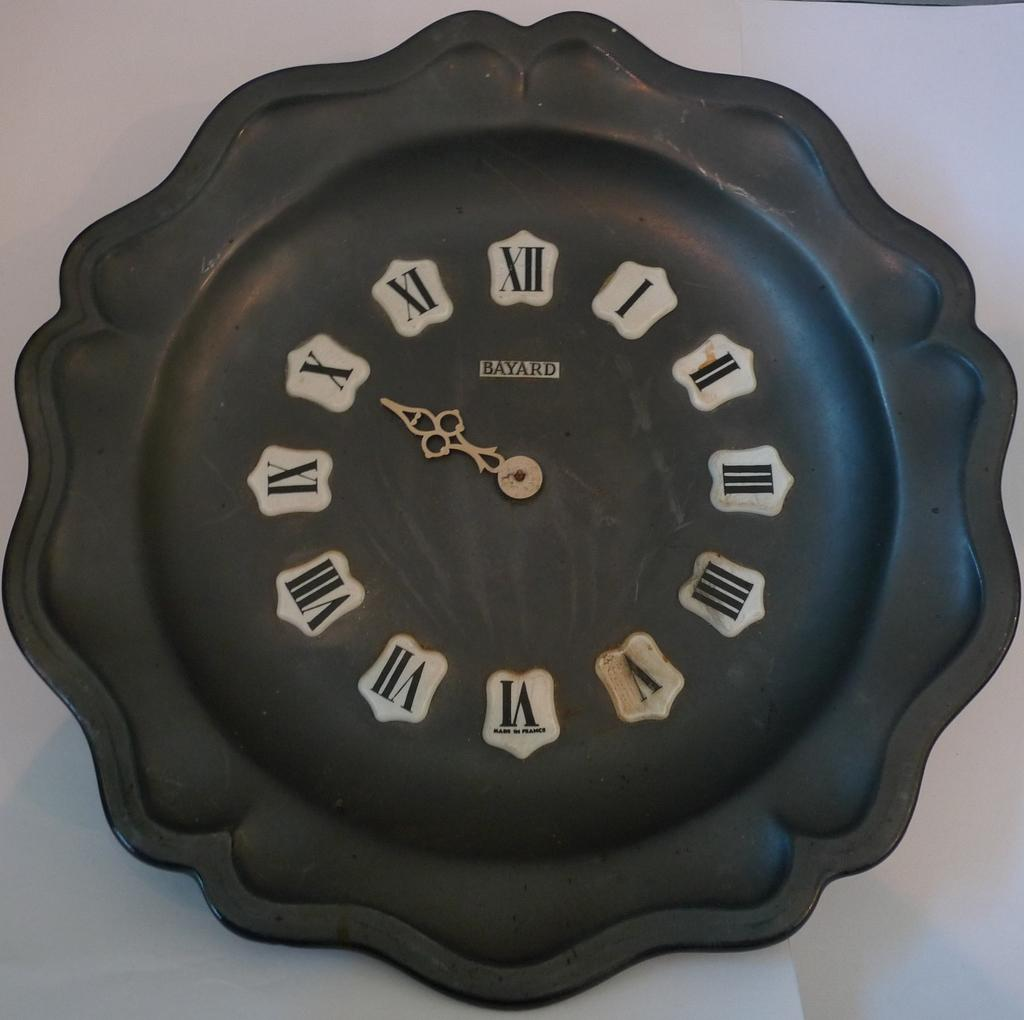<image>
Render a clear and concise summary of the photo. Bayard manufactuered the black clock on the wall. 